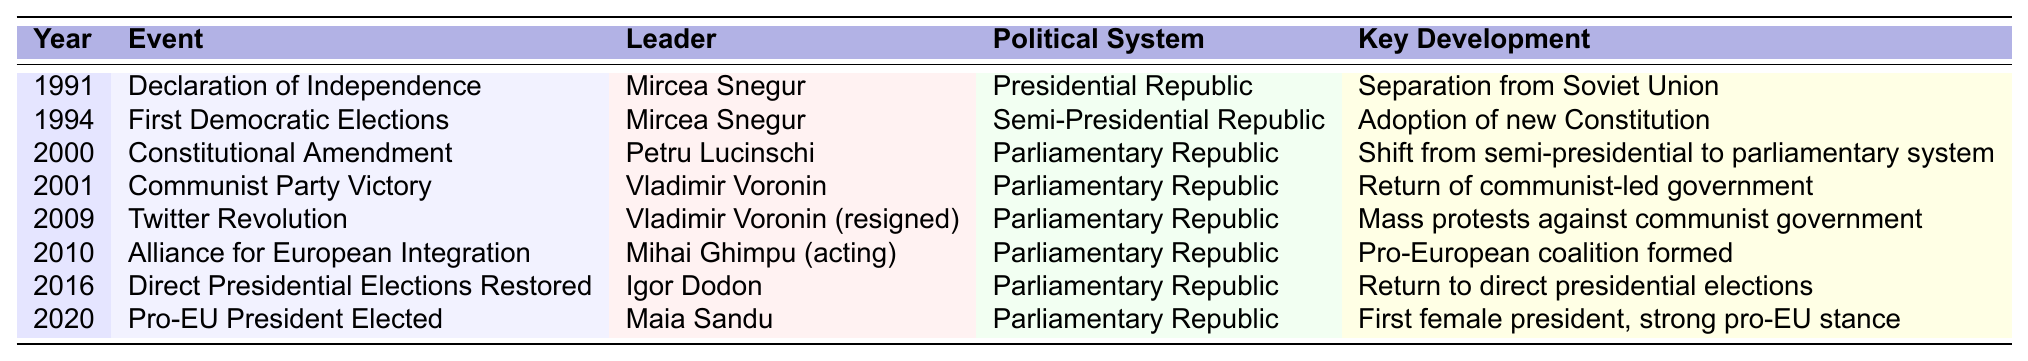What year did Moldova declare independence? The table indicates that Moldova declared independence in the year 1991.
Answer: 1991 Who was the leader during the first democratic elections? The table shows that Mircea Snegur was the leader during the first democratic elections in 1994.
Answer: Mircea Snegur What political system was in place in Moldova after the constitutional amendment in 2000? The table states that after the constitutional amendment in 2000, Moldova was a Parliamentary Republic.
Answer: Parliamentary Republic Was there a shift from a presidential system to a parliamentary system in Moldova in the year 2000? Yes, the table indicates that there was a shift from a semi-presidential to a parliamentary system in 2000.
Answer: Yes How many events led to a change in the political system of Moldova since its independence? Based on the table, there were two events leading to a change in the political system: the 2000 constitutional amendment and the 1994 transition.
Answer: 2 In what year did Moldova experience the "Twitter Revolution"? According to the table, the "Twitter Revolution" occurred in the year 2009.
Answer: 2009 Which leader was in power when the pro-EU president was elected in 2020? The table shows that Maia Sandu was elected as the pro-EU president in 2020.
Answer: Maia Sandu What political development occurred after the 2009 protests against the communist government? The table indicates that after the protests in 2009, an Alliance for European Integration was formed in 2010.
Answer: Alliance for European Integration Which political leader was in power from 2001 to 2009? Based on the table, Vladimir Voronin was the leader in power from 2001 until he resigned in 2009.
Answer: Vladimir Voronin How many times did Moldova's political system change from 1991 to 2020? The table presents a total of three political system changes: in 1994, 2000, and the restoration of presidential elections in 2016.
Answer: 3 What does the key development note for the year 2016 indicate? The key development for the year 2016 notes the return to direct presidential elections in Moldova.
Answer: Return to direct presidential elections Which event followed the resignation of Vladimir Voronin? According to the table, the event that followed Vladimir Voronin's resignation was the formation of the Alliance for European Integration in 2010.
Answer: Alliance for European Integration Was Mircea Snegur the leader during both the declaration of independence and the first democratic elections? Yes, the table confirms that Mircea Snegur was the leader in both instances in 1991 and 1994.
Answer: Yes What is the significance of the election of Maia Sandu in 2020 according to the table? The significance is noted as the election of the first female president of Moldova with a strong pro-EU stance.
Answer: First female president, strong pro-EU stance Which event marks the return of a communist-led government in Moldova? The table indicates that the Communist Party Victory in 2001 marks the return of a communist-led government.
Answer: Communist Party Victory in 2001 How did the political system of Moldova evolve from 1991 to 2020 based on the table? The evolution shows a transition from a Presidential Republic in 1991 to a Semi-Presidential Republic in 1994, followed by a shift to a Parliamentary Republic in 2000, continuing as such until 2020.
Answer: Evolved to Parliamentary Republic 